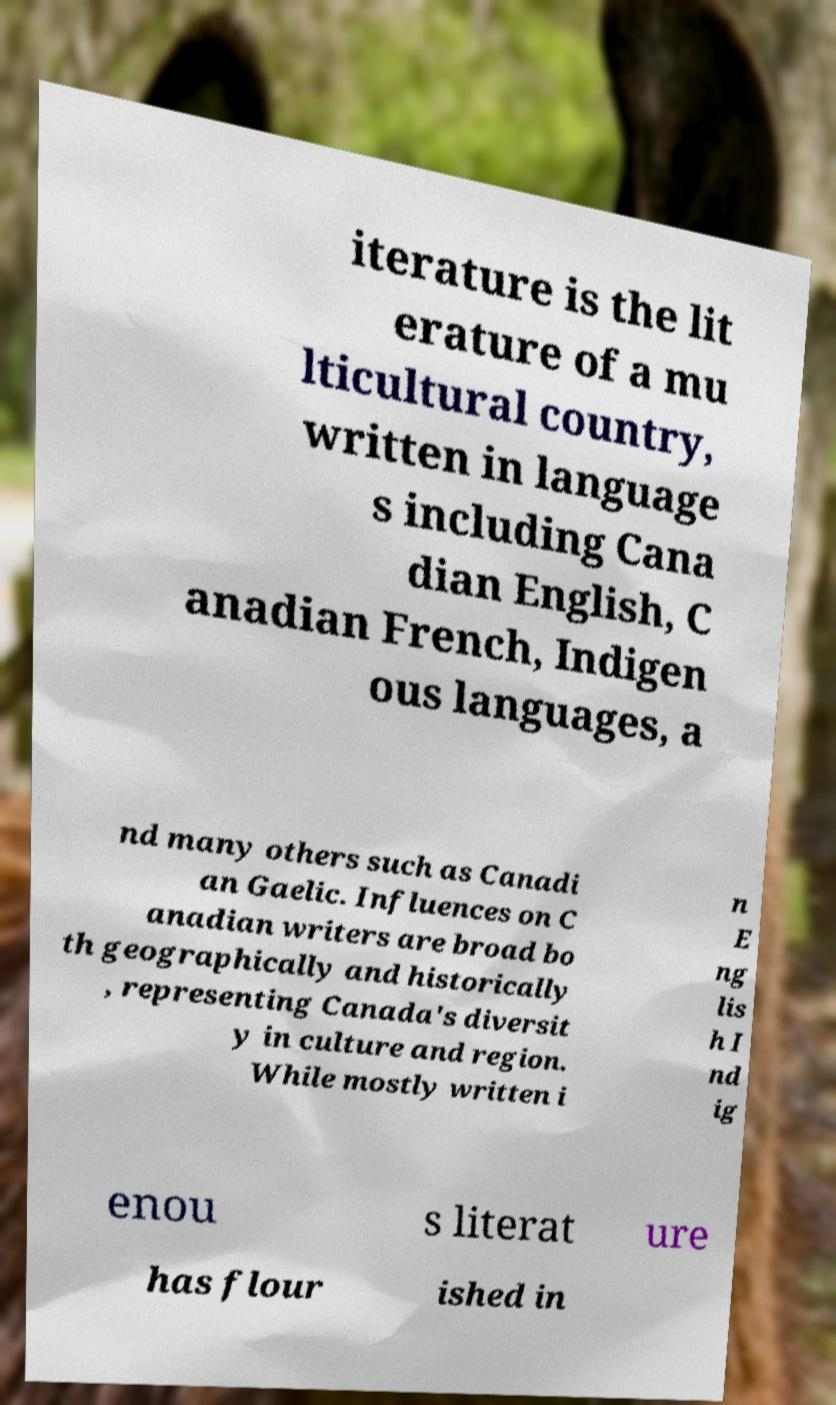There's text embedded in this image that I need extracted. Can you transcribe it verbatim? iterature is the lit erature of a mu lticultural country, written in language s including Cana dian English, C anadian French, Indigen ous languages, a nd many others such as Canadi an Gaelic. Influences on C anadian writers are broad bo th geographically and historically , representing Canada's diversit y in culture and region. While mostly written i n E ng lis h I nd ig enou s literat ure has flour ished in 